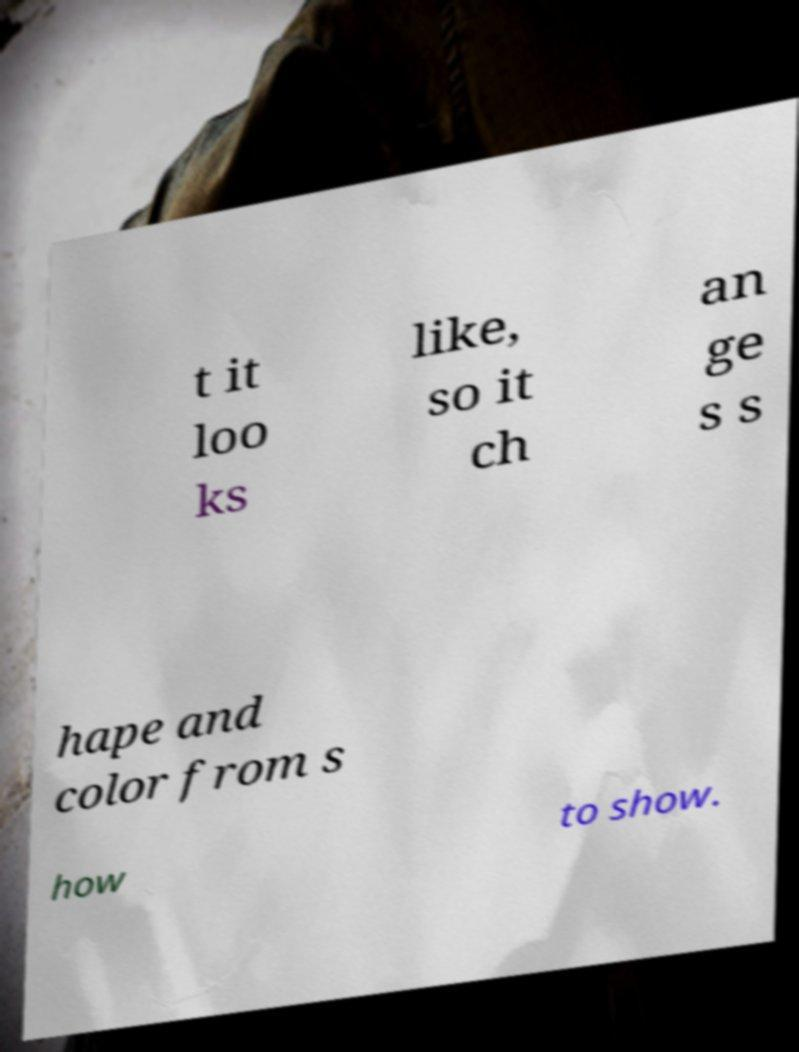What messages or text are displayed in this image? I need them in a readable, typed format. t it loo ks like, so it ch an ge s s hape and color from s how to show. 